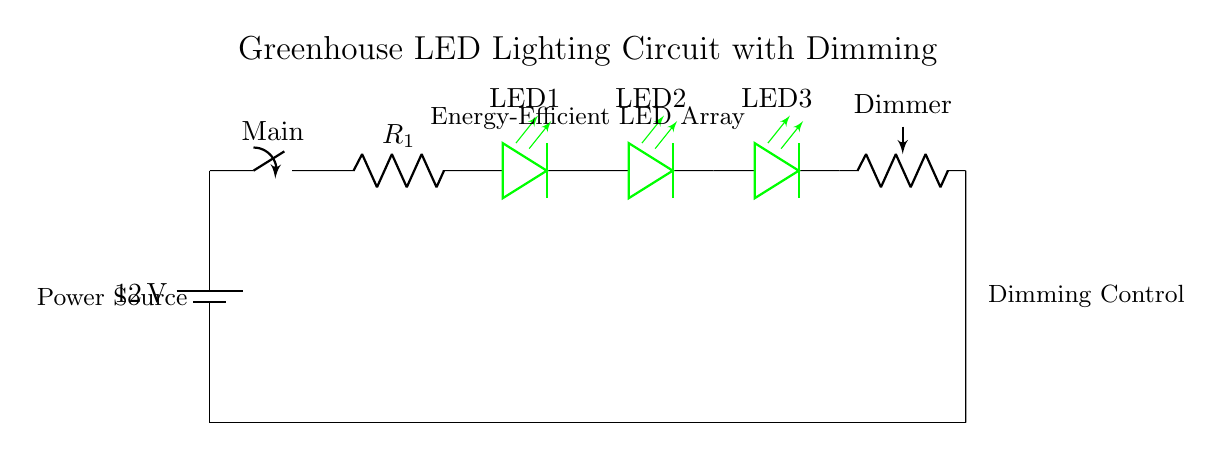What is the voltage supplied to the circuit? The voltage supplied to the circuit is 12 volts, as indicated by the battery symbol in the circuit diagram.
Answer: 12 volts What type of components are used for lighting? The components used for lighting in this circuit are LEDs, which are depicted as leDo symbols in green color in the diagram.
Answer: LEDs What is the purpose of the dimming potentiometer? The dimming potentiometer is used to adjust the brightness of the LED array, allowing for better control of light levels in the greenhouse.
Answer: Brightness control How many LED lights are in the circuit? There are three LED lights shown in the diagram, represented as LED1, LED2, and LED3.
Answer: Three How does the dimmer affect the current? The dimmer affects the current by varying resistance; as the potentiometer is adjusted, it changes the amount of current flowing through the LEDs, impacting their brightness.
Answer: Varies current What is the role of the main switch in the circuit? The main switch allows the user to turn the entire lighting circuit on or off, effectively controlling the power supply to the LEDs and dimmer.
Answer: Power control What component limits the current in the circuit? The current limiting resistor, labeled R1, is responsible for limiting the current to protect the LEDs from excessive current that could damage them.
Answer: Current limiting resistor 